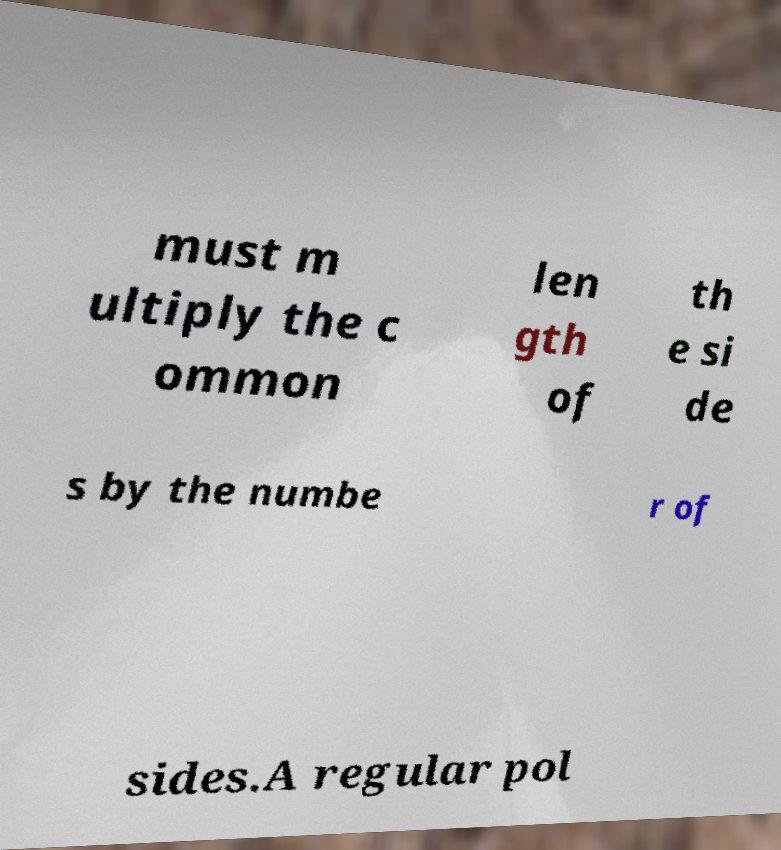There's text embedded in this image that I need extracted. Can you transcribe it verbatim? must m ultiply the c ommon len gth of th e si de s by the numbe r of sides.A regular pol 